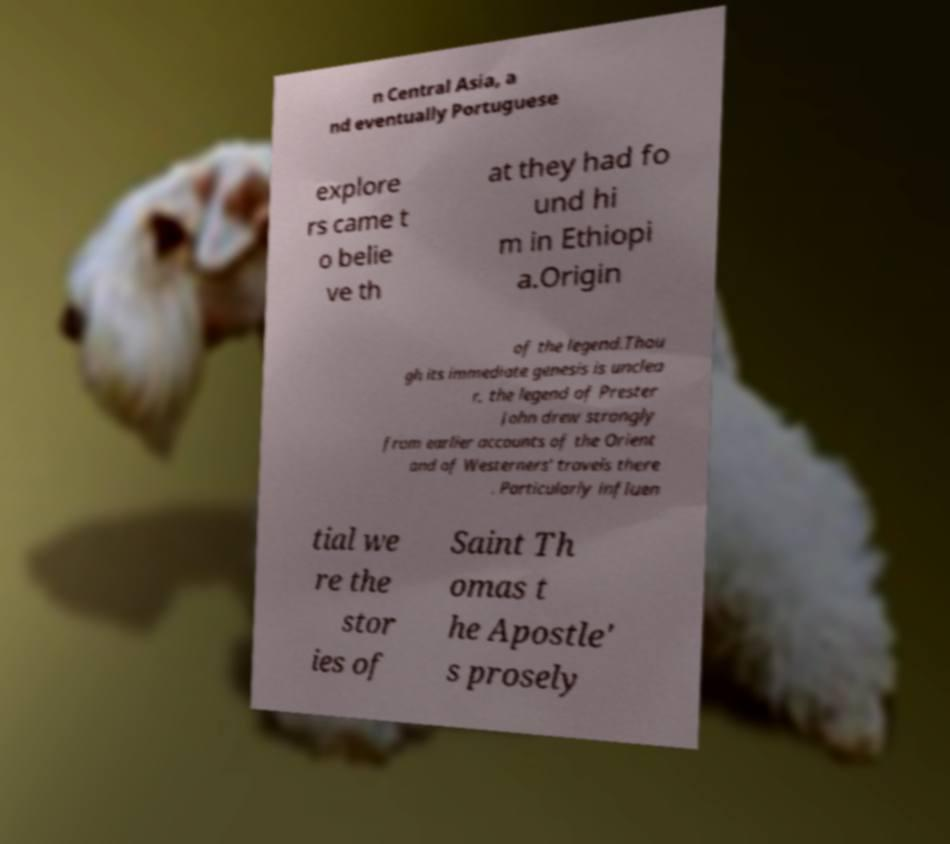There's text embedded in this image that I need extracted. Can you transcribe it verbatim? n Central Asia, a nd eventually Portuguese explore rs came t o belie ve th at they had fo und hi m in Ethiopi a.Origin of the legend.Thou gh its immediate genesis is unclea r, the legend of Prester John drew strongly from earlier accounts of the Orient and of Westerners' travels there . Particularly influen tial we re the stor ies of Saint Th omas t he Apostle' s prosely 